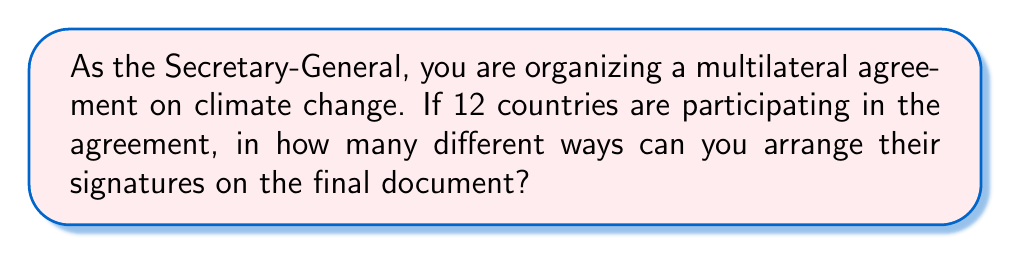Can you solve this math problem? To solve this problem, we need to understand that this is a permutation question. We are arranging all 12 countries in a specific order, and the order matters (as it might have diplomatic implications).

The number of ways to arrange n distinct objects is given by the factorial of n, denoted as n!

In this case, n = 12 (the number of countries)

So, the number of ways to arrange the signatures is:

$$ 12! = 12 \times 11 \times 10 \times 9 \times 8 \times 7 \times 6 \times 5 \times 4 \times 3 \times 2 \times 1 $$

Let's calculate this step by step:

$$ \begin{align*}
12! &= 12 \times 11 \times 10 \times 9 \times 8 \times 7 \times 6 \times 5 \times 4 \times 3 \times 2 \times 1 \\
&= 479,001,600
\end{align*} $$

Therefore, there are 479,001,600 different ways to arrange the signatures of the 12 countries on the multilateral agreement.
Answer: $479,001,600$ 